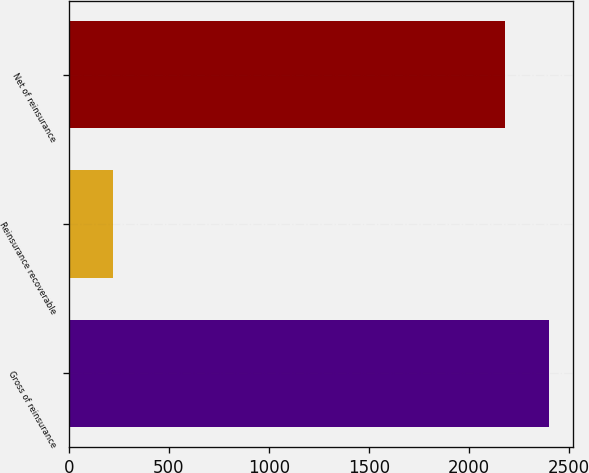<chart> <loc_0><loc_0><loc_500><loc_500><bar_chart><fcel>Gross of reinsurance<fcel>Reinsurance recoverable<fcel>Net of reinsurance<nl><fcel>2401<fcel>219<fcel>2182<nl></chart> 